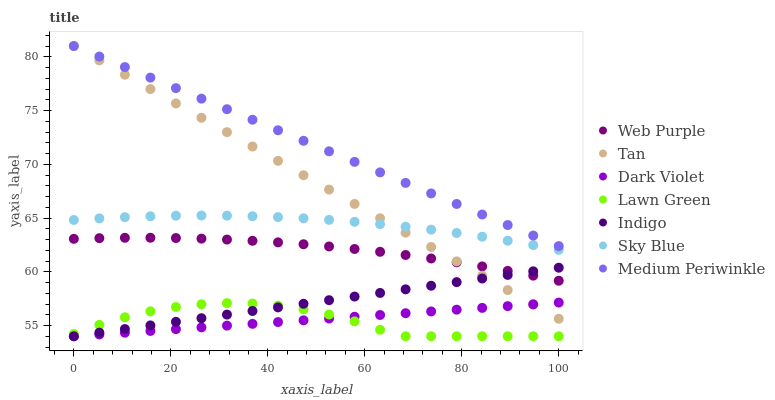Does Lawn Green have the minimum area under the curve?
Answer yes or no. Yes. Does Medium Periwinkle have the maximum area under the curve?
Answer yes or no. Yes. Does Indigo have the minimum area under the curve?
Answer yes or no. No. Does Indigo have the maximum area under the curve?
Answer yes or no. No. Is Dark Violet the smoothest?
Answer yes or no. Yes. Is Lawn Green the roughest?
Answer yes or no. Yes. Is Indigo the smoothest?
Answer yes or no. No. Is Indigo the roughest?
Answer yes or no. No. Does Lawn Green have the lowest value?
Answer yes or no. Yes. Does Medium Periwinkle have the lowest value?
Answer yes or no. No. Does Tan have the highest value?
Answer yes or no. Yes. Does Indigo have the highest value?
Answer yes or no. No. Is Lawn Green less than Medium Periwinkle?
Answer yes or no. Yes. Is Medium Periwinkle greater than Indigo?
Answer yes or no. Yes. Does Indigo intersect Lawn Green?
Answer yes or no. Yes. Is Indigo less than Lawn Green?
Answer yes or no. No. Is Indigo greater than Lawn Green?
Answer yes or no. No. Does Lawn Green intersect Medium Periwinkle?
Answer yes or no. No. 